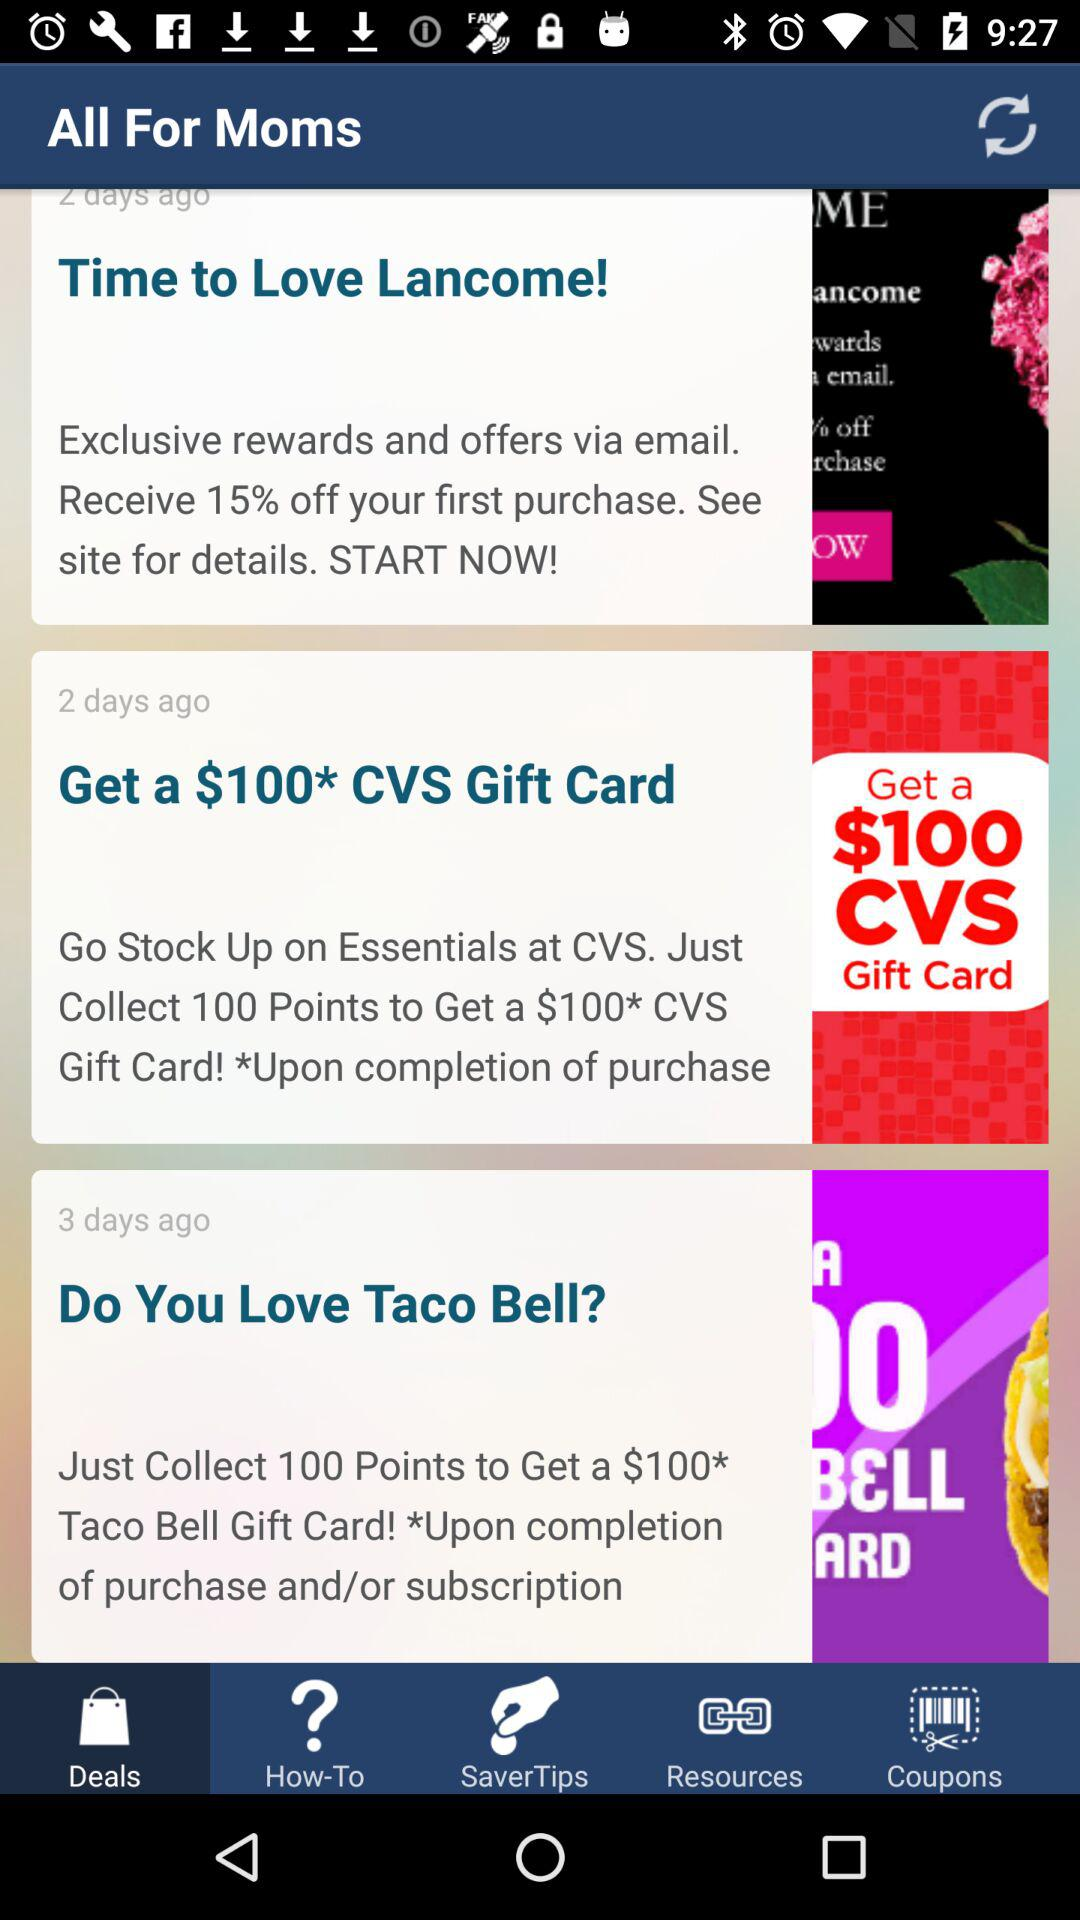Which tab is selected? The selected tab is "Deals". 